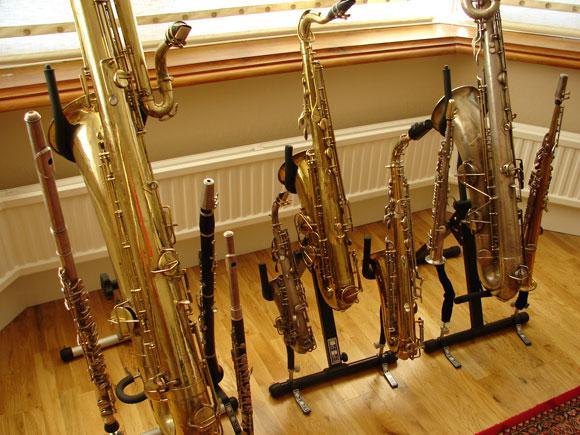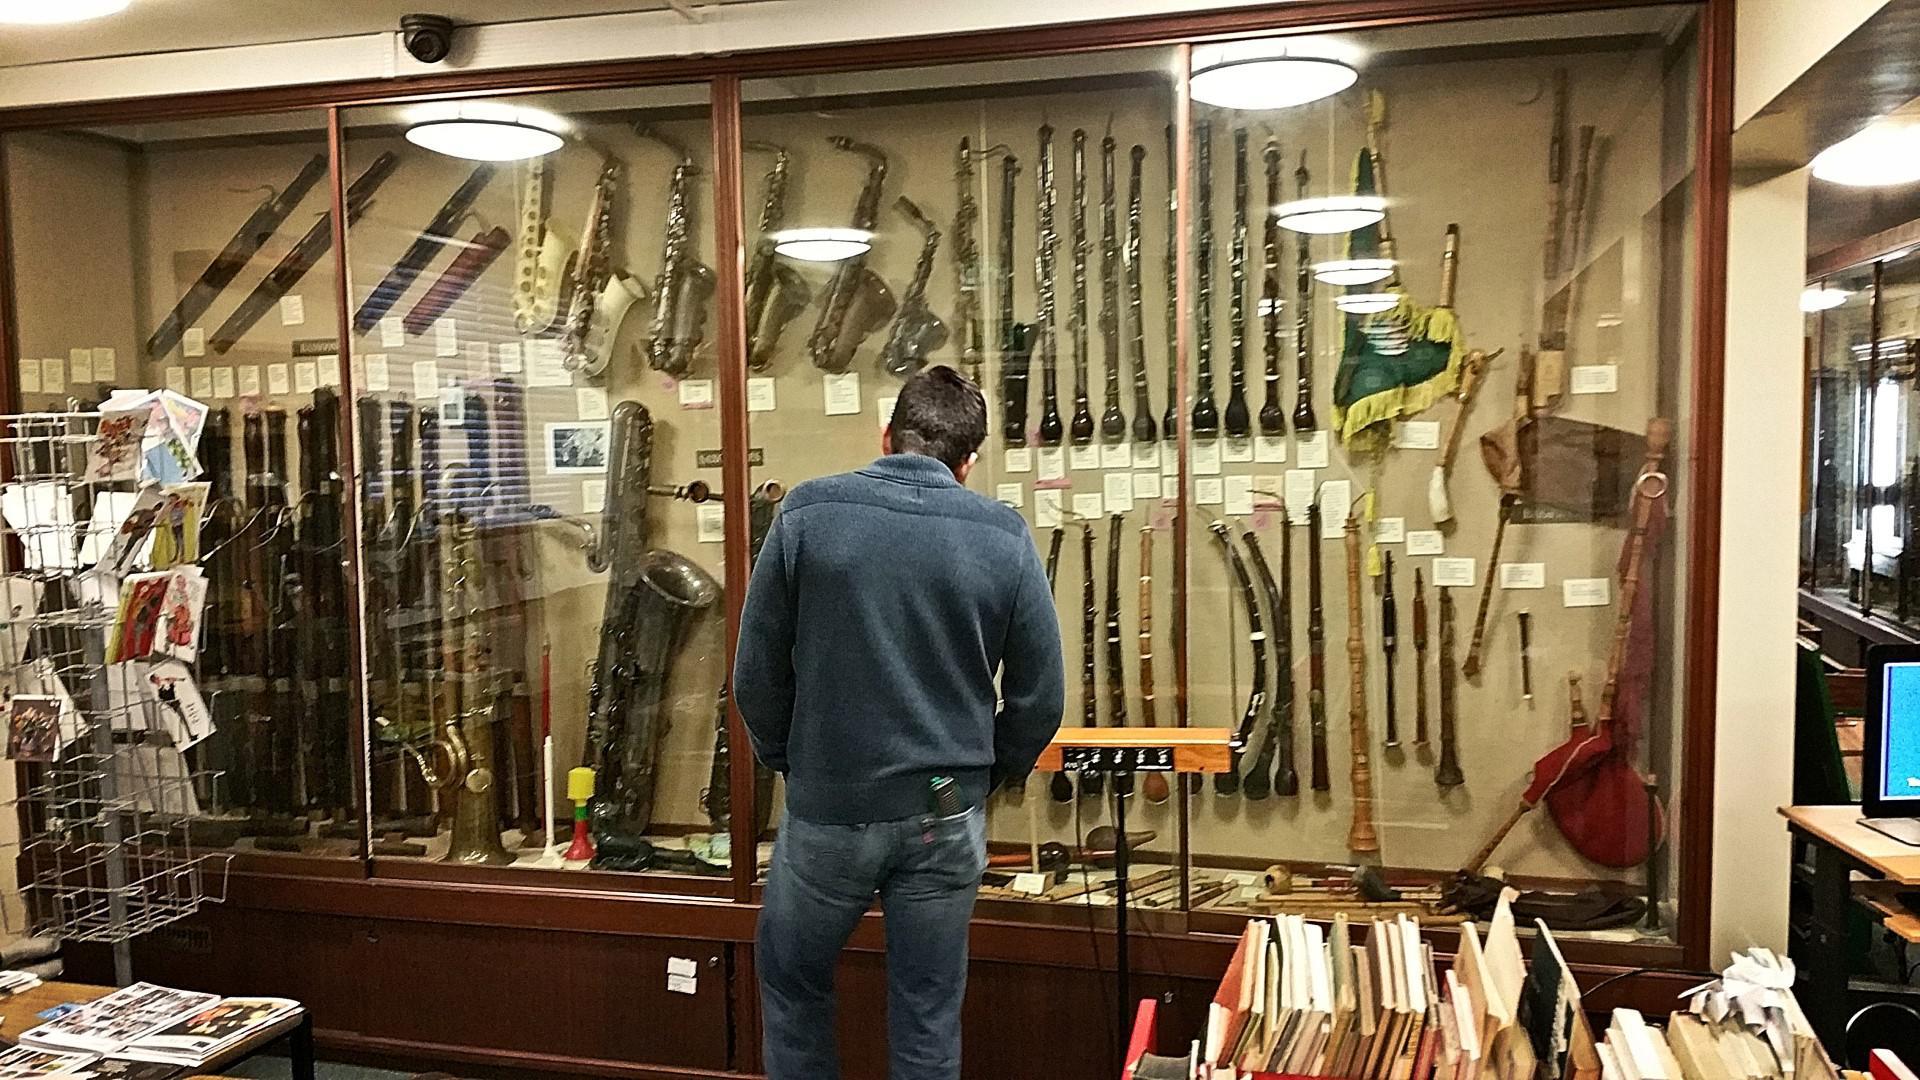The first image is the image on the left, the second image is the image on the right. Analyze the images presented: Is the assertion "The trombone is facing to the right in the right image." valid? Answer yes or no. No. The first image is the image on the left, the second image is the image on the right. Considering the images on both sides, is "The left and right image contains the same number of saxophones being held by their stand alone." valid? Answer yes or no. No. 